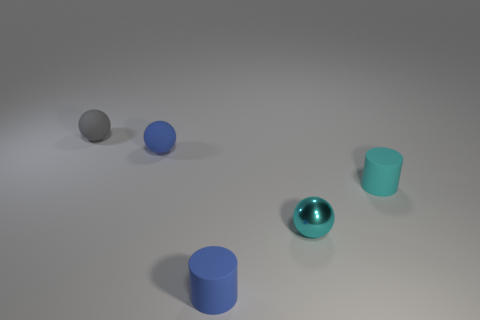Add 5 small shiny things. How many objects exist? 10 Subtract all spheres. How many objects are left? 2 Subtract all tiny spheres. Subtract all small gray things. How many objects are left? 1 Add 4 tiny blue matte balls. How many tiny blue matte balls are left? 5 Add 5 big green spheres. How many big green spheres exist? 5 Subtract 1 cyan cylinders. How many objects are left? 4 